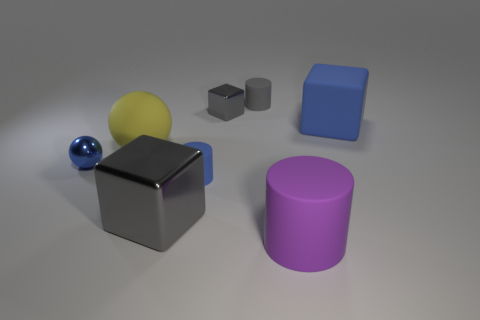Subtract all blue cubes. How many cubes are left? 2 Add 2 matte spheres. How many objects exist? 10 Subtract all blue blocks. How many blocks are left? 2 Subtract 1 cubes. How many cubes are left? 2 Subtract all spheres. How many objects are left? 6 Subtract all green cylinders. Subtract all cyan blocks. How many cylinders are left? 3 Subtract all red spheres. How many blue cylinders are left? 1 Subtract all blocks. Subtract all big purple rubber cylinders. How many objects are left? 4 Add 7 blue objects. How many blue objects are left? 10 Add 7 tiny blue matte objects. How many tiny blue matte objects exist? 8 